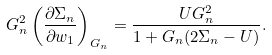Convert formula to latex. <formula><loc_0><loc_0><loc_500><loc_500>G _ { n } ^ { 2 } \left ( \frac { \partial \Sigma _ { n } } { \partial w _ { 1 } } \right ) _ { G _ { n } } = \frac { U G _ { n } ^ { 2 } } { 1 + G _ { n } ( 2 \Sigma _ { n } - U ) } .</formula> 